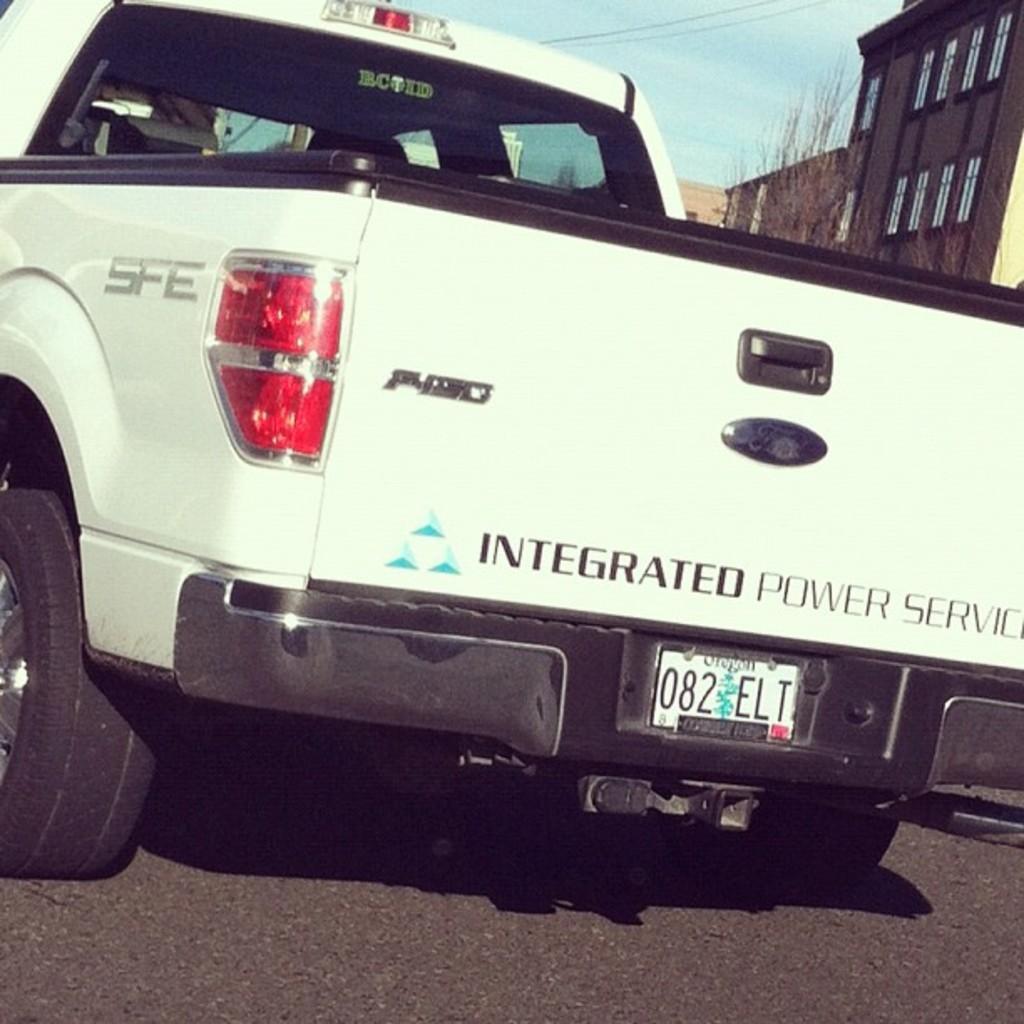Can you describe this image briefly? In this image I can see a vehicle on the road. In the top right corner, I can see the buildings and the sky. 